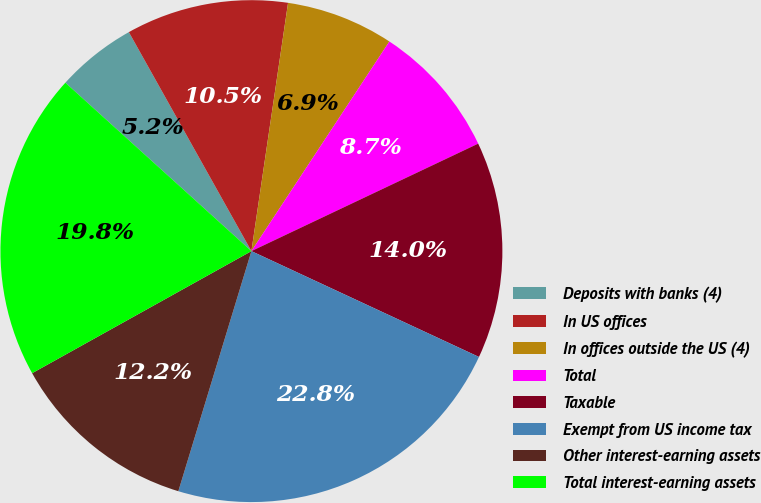<chart> <loc_0><loc_0><loc_500><loc_500><pie_chart><fcel>Deposits with banks (4)<fcel>In US offices<fcel>In offices outside the US (4)<fcel>Total<fcel>Taxable<fcel>Exempt from US income tax<fcel>Other interest-earning assets<fcel>Total interest-earning assets<nl><fcel>5.17%<fcel>10.45%<fcel>6.93%<fcel>8.69%<fcel>13.97%<fcel>22.77%<fcel>12.21%<fcel>19.79%<nl></chart> 